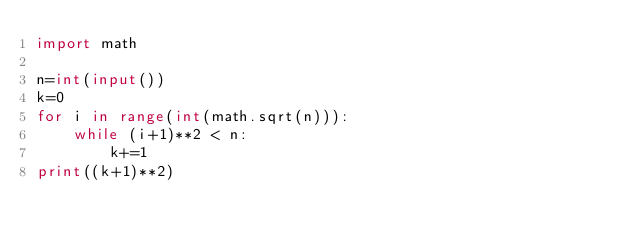<code> <loc_0><loc_0><loc_500><loc_500><_Python_>import math

n=int(input())
k=0
for i in range(int(math.sqrt(n))):
    while (i+1)**2 < n:
        k+=1
print((k+1)**2)
</code> 